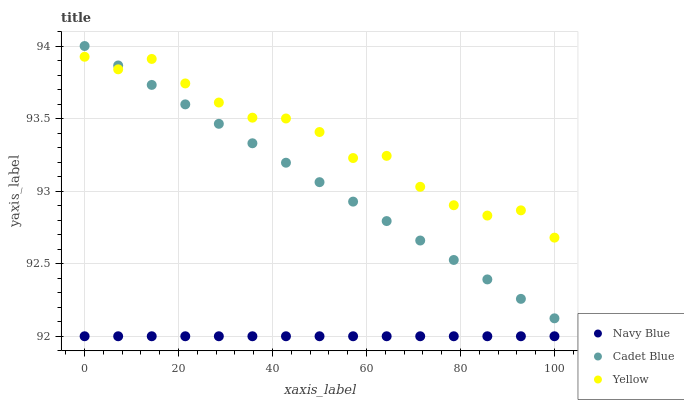Does Navy Blue have the minimum area under the curve?
Answer yes or no. Yes. Does Yellow have the maximum area under the curve?
Answer yes or no. Yes. Does Cadet Blue have the minimum area under the curve?
Answer yes or no. No. Does Cadet Blue have the maximum area under the curve?
Answer yes or no. No. Is Navy Blue the smoothest?
Answer yes or no. Yes. Is Yellow the roughest?
Answer yes or no. Yes. Is Cadet Blue the smoothest?
Answer yes or no. No. Is Cadet Blue the roughest?
Answer yes or no. No. Does Navy Blue have the lowest value?
Answer yes or no. Yes. Does Cadet Blue have the lowest value?
Answer yes or no. No. Does Cadet Blue have the highest value?
Answer yes or no. Yes. Does Yellow have the highest value?
Answer yes or no. No. Is Navy Blue less than Yellow?
Answer yes or no. Yes. Is Cadet Blue greater than Navy Blue?
Answer yes or no. Yes. Does Yellow intersect Cadet Blue?
Answer yes or no. Yes. Is Yellow less than Cadet Blue?
Answer yes or no. No. Is Yellow greater than Cadet Blue?
Answer yes or no. No. Does Navy Blue intersect Yellow?
Answer yes or no. No. 